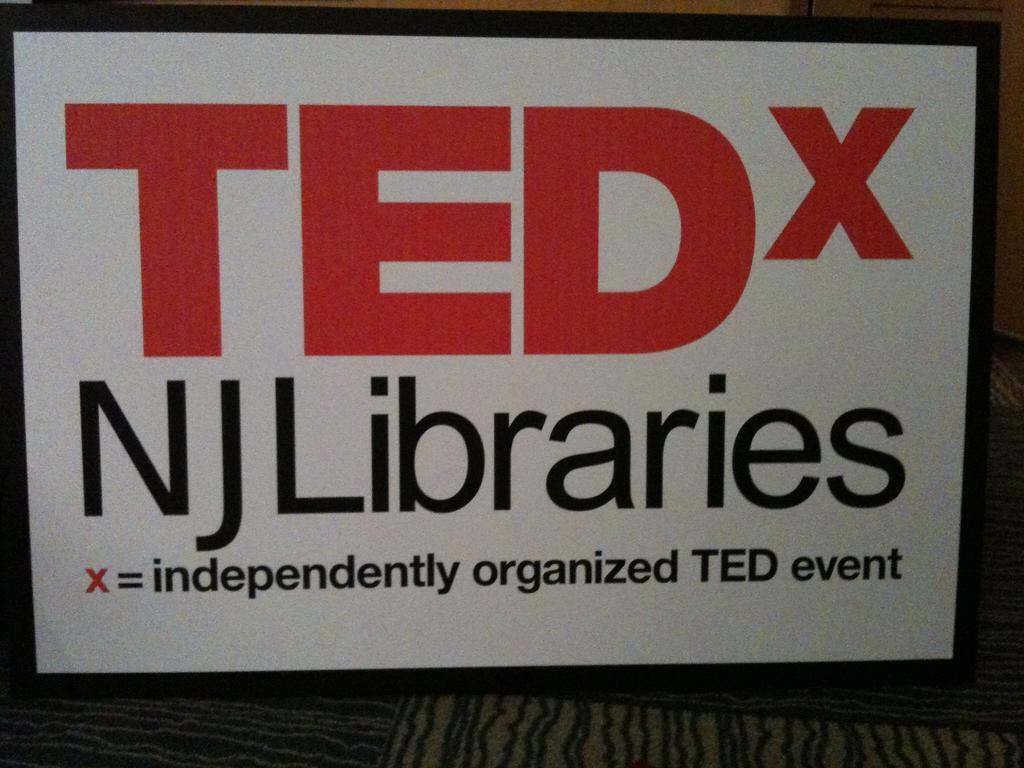<image>
Offer a succinct explanation of the picture presented. The x in the image indicates it's an independently organized event. 